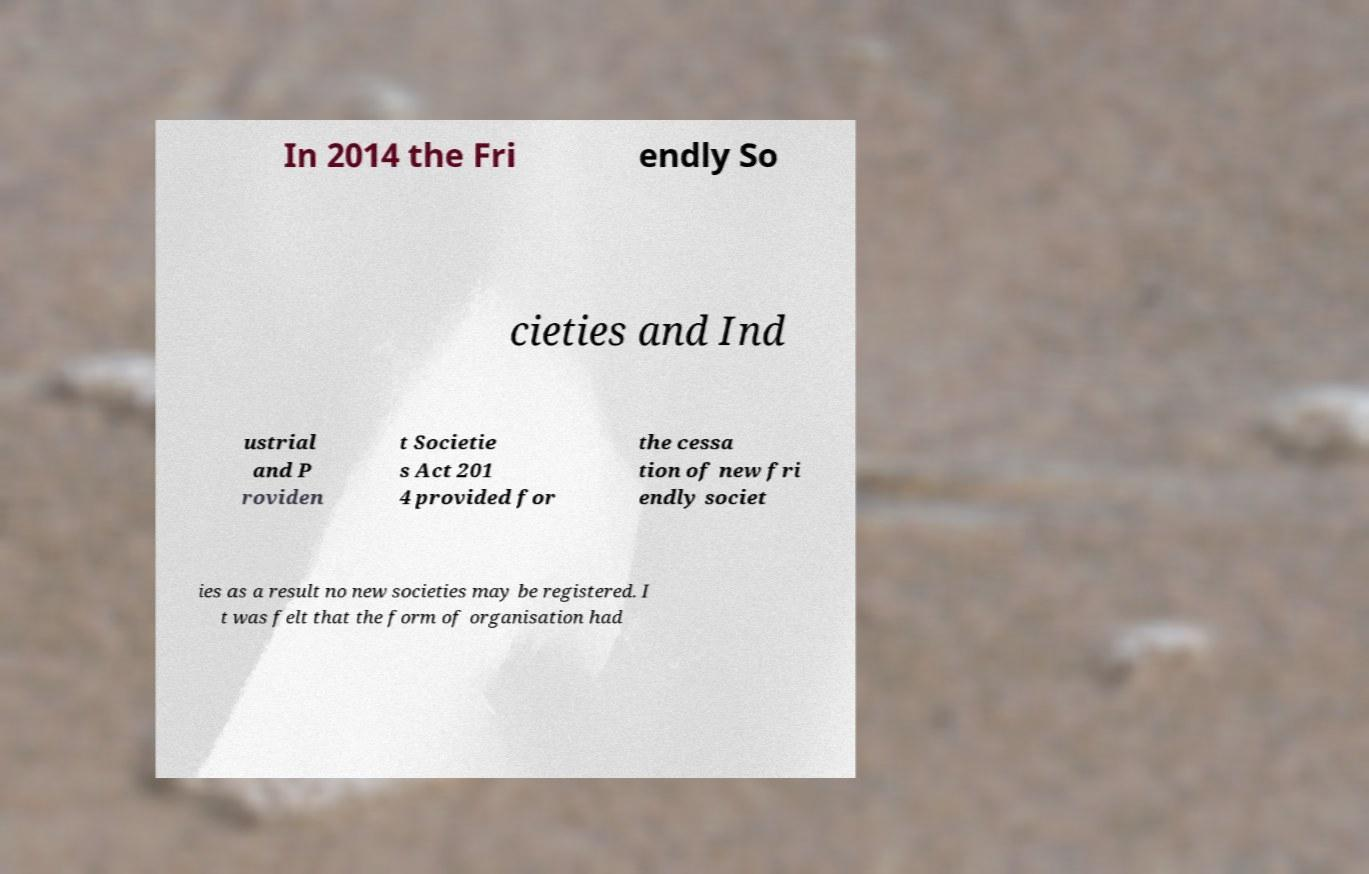I need the written content from this picture converted into text. Can you do that? In 2014 the Fri endly So cieties and Ind ustrial and P roviden t Societie s Act 201 4 provided for the cessa tion of new fri endly societ ies as a result no new societies may be registered. I t was felt that the form of organisation had 